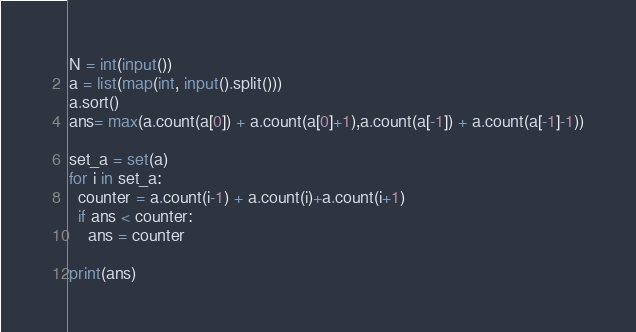<code> <loc_0><loc_0><loc_500><loc_500><_Python_>N = int(input())
a = list(map(int, input().split()))
a.sort()
ans= max(a.count(a[0]) + a.count(a[0]+1),a.count(a[-1]) + a.count(a[-1]-1))

set_a = set(a)
for i in set_a:
  counter = a.count(i-1) + a.count(i)+a.count(i+1)
  if ans < counter:
    ans = counter
  
print(ans)</code> 